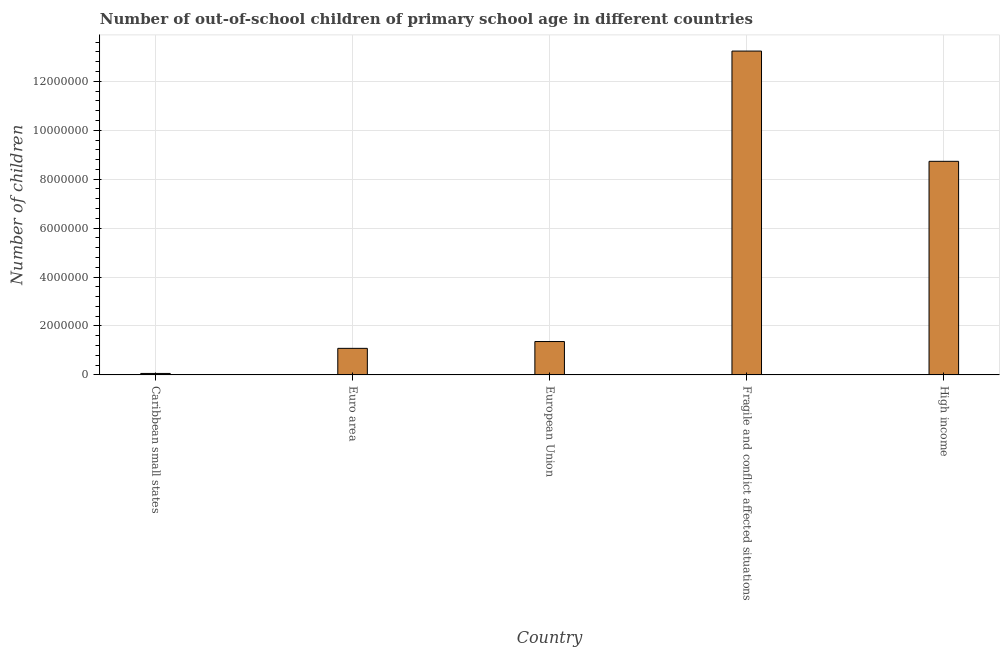What is the title of the graph?
Offer a terse response. Number of out-of-school children of primary school age in different countries. What is the label or title of the X-axis?
Offer a terse response. Country. What is the label or title of the Y-axis?
Your answer should be very brief. Number of children. What is the number of out-of-school children in Euro area?
Your answer should be very brief. 1.09e+06. Across all countries, what is the maximum number of out-of-school children?
Your answer should be compact. 1.32e+07. Across all countries, what is the minimum number of out-of-school children?
Your response must be concise. 6.01e+04. In which country was the number of out-of-school children maximum?
Offer a very short reply. Fragile and conflict affected situations. In which country was the number of out-of-school children minimum?
Make the answer very short. Caribbean small states. What is the sum of the number of out-of-school children?
Your answer should be compact. 2.45e+07. What is the difference between the number of out-of-school children in European Union and High income?
Give a very brief answer. -7.37e+06. What is the average number of out-of-school children per country?
Your response must be concise. 4.90e+06. What is the median number of out-of-school children?
Make the answer very short. 1.36e+06. What is the ratio of the number of out-of-school children in Caribbean small states to that in Fragile and conflict affected situations?
Provide a succinct answer. 0.01. Is the number of out-of-school children in Euro area less than that in High income?
Your response must be concise. Yes. What is the difference between the highest and the second highest number of out-of-school children?
Make the answer very short. 4.51e+06. What is the difference between the highest and the lowest number of out-of-school children?
Ensure brevity in your answer.  1.32e+07. How many bars are there?
Make the answer very short. 5. What is the Number of children of Caribbean small states?
Offer a very short reply. 6.01e+04. What is the Number of children in Euro area?
Keep it short and to the point. 1.09e+06. What is the Number of children in European Union?
Offer a terse response. 1.36e+06. What is the Number of children in Fragile and conflict affected situations?
Keep it short and to the point. 1.32e+07. What is the Number of children in High income?
Ensure brevity in your answer.  8.73e+06. What is the difference between the Number of children in Caribbean small states and Euro area?
Your answer should be very brief. -1.03e+06. What is the difference between the Number of children in Caribbean small states and European Union?
Your answer should be compact. -1.30e+06. What is the difference between the Number of children in Caribbean small states and Fragile and conflict affected situations?
Ensure brevity in your answer.  -1.32e+07. What is the difference between the Number of children in Caribbean small states and High income?
Ensure brevity in your answer.  -8.67e+06. What is the difference between the Number of children in Euro area and European Union?
Keep it short and to the point. -2.79e+05. What is the difference between the Number of children in Euro area and Fragile and conflict affected situations?
Provide a succinct answer. -1.22e+07. What is the difference between the Number of children in Euro area and High income?
Offer a terse response. -7.65e+06. What is the difference between the Number of children in European Union and Fragile and conflict affected situations?
Your response must be concise. -1.19e+07. What is the difference between the Number of children in European Union and High income?
Make the answer very short. -7.37e+06. What is the difference between the Number of children in Fragile and conflict affected situations and High income?
Ensure brevity in your answer.  4.51e+06. What is the ratio of the Number of children in Caribbean small states to that in Euro area?
Offer a terse response. 0.06. What is the ratio of the Number of children in Caribbean small states to that in European Union?
Your response must be concise. 0.04. What is the ratio of the Number of children in Caribbean small states to that in Fragile and conflict affected situations?
Your answer should be very brief. 0.01. What is the ratio of the Number of children in Caribbean small states to that in High income?
Keep it short and to the point. 0.01. What is the ratio of the Number of children in Euro area to that in European Union?
Keep it short and to the point. 0.8. What is the ratio of the Number of children in Euro area to that in Fragile and conflict affected situations?
Provide a short and direct response. 0.08. What is the ratio of the Number of children in Euro area to that in High income?
Provide a short and direct response. 0.12. What is the ratio of the Number of children in European Union to that in Fragile and conflict affected situations?
Your response must be concise. 0.1. What is the ratio of the Number of children in European Union to that in High income?
Ensure brevity in your answer.  0.16. What is the ratio of the Number of children in Fragile and conflict affected situations to that in High income?
Your answer should be compact. 1.52. 